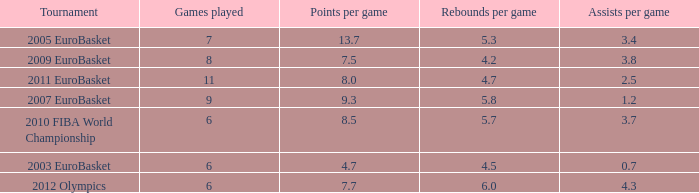How many games played have 4.7 as points per game? 6.0. 